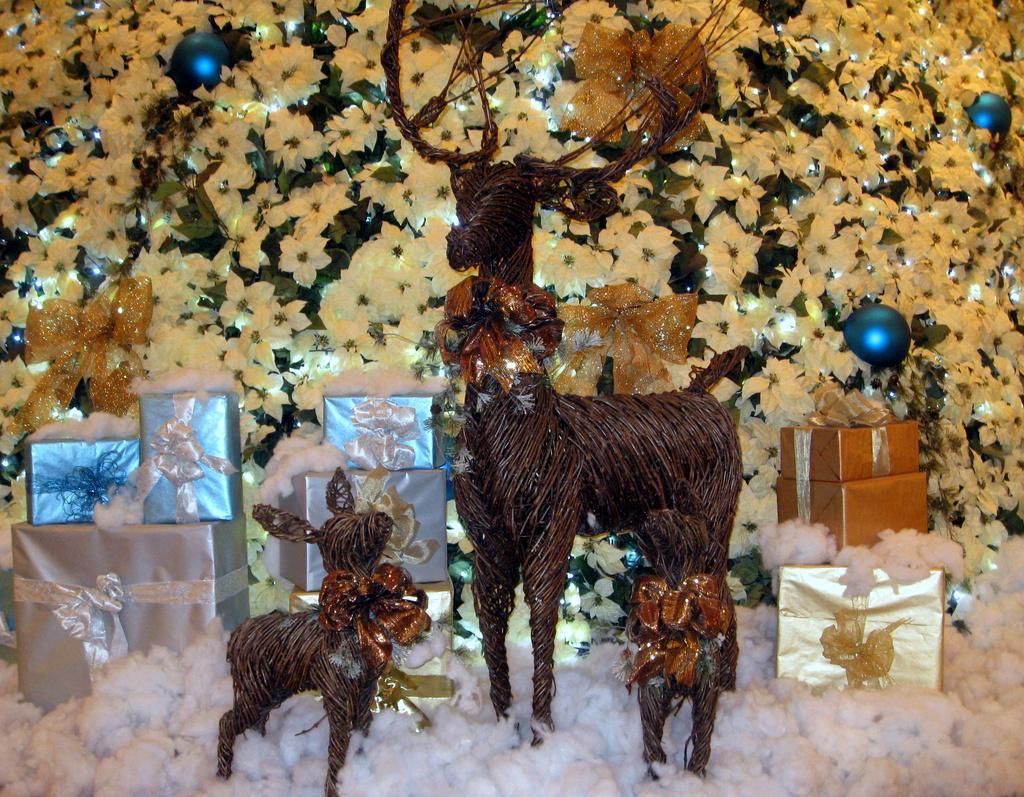In one or two sentences, can you explain what this image depicts? In this picture I can see flowers and toys. I can also see some gift boxes. 